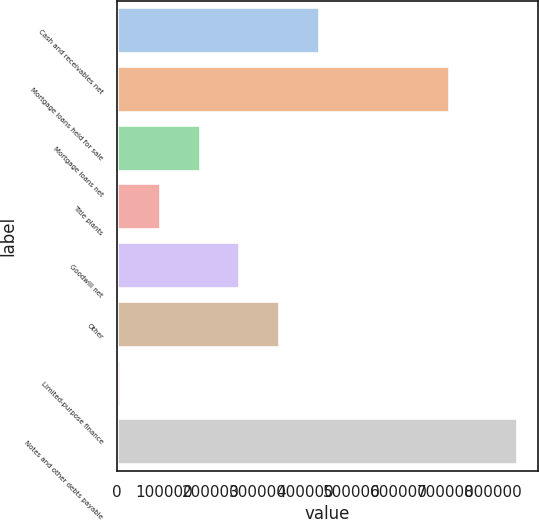Convert chart to OTSL. <chart><loc_0><loc_0><loc_500><loc_500><bar_chart><fcel>Cash and receivables net<fcel>Mortgage loans held for sale<fcel>Mortgage loans net<fcel>Title plants<fcel>Goodwill net<fcel>Other<fcel>Limited-purpose finance<fcel>Notes and other debts payable<nl><fcel>431309<fcel>708304<fcel>178045<fcel>93623.4<fcel>262466<fcel>346888<fcel>9202<fcel>853416<nl></chart> 